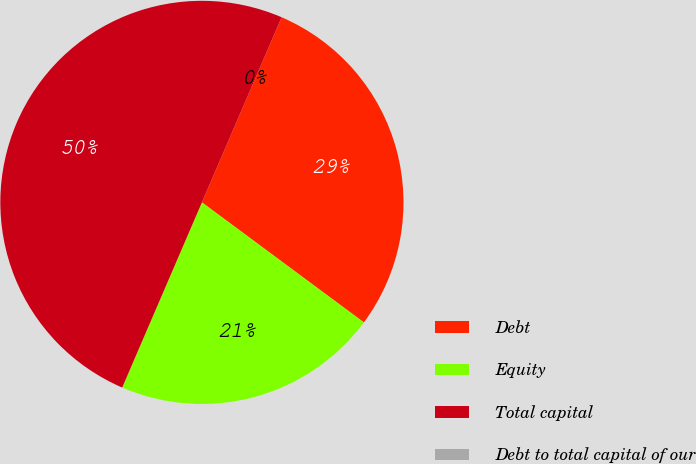<chart> <loc_0><loc_0><loc_500><loc_500><pie_chart><fcel>Debt<fcel>Equity<fcel>Total capital<fcel>Debt to total capital of our<nl><fcel>28.68%<fcel>21.32%<fcel>50.0%<fcel>0.0%<nl></chart> 